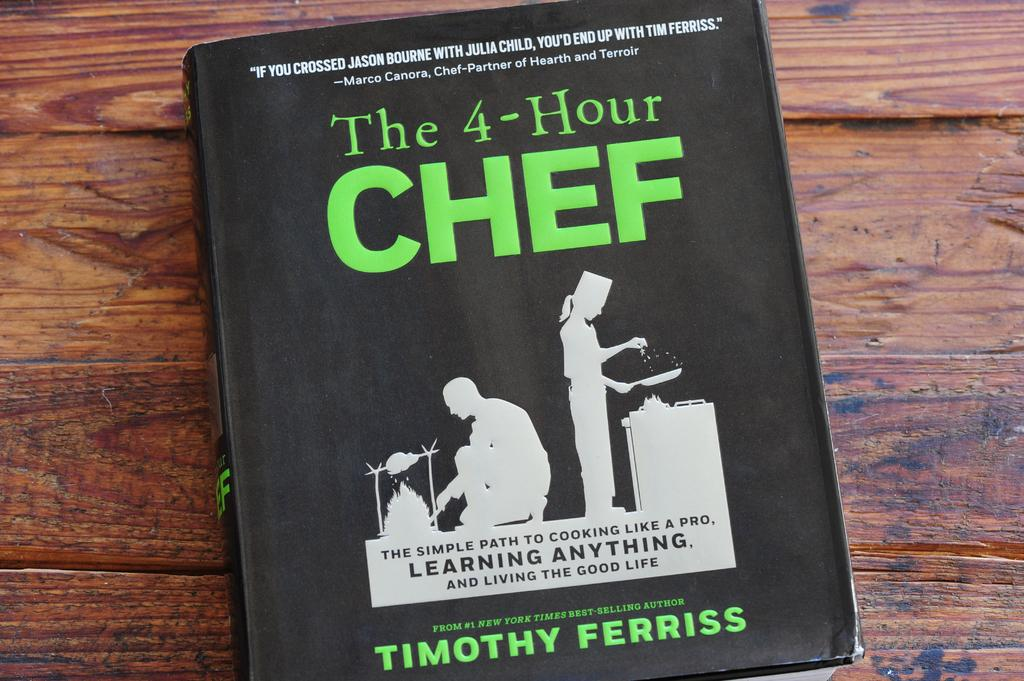<image>
Describe the image concisely. Book with green letters that say The 4-Hour Chef. 